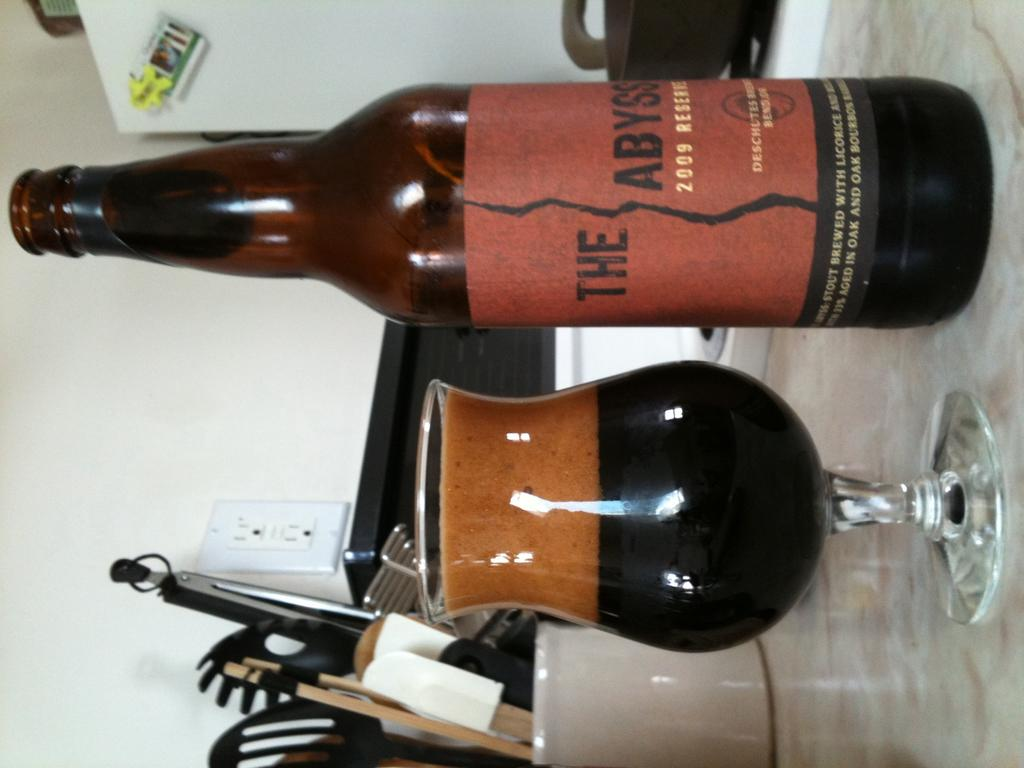What type of container is visible in the image? There is a glass in the image. What other container can be seen in the image? There is a bottle in the image. Can you identify any text or writing in the image? Yes, there is writing on an object in the image. What can be seen in the background of the image? There are background elements visible in the image. What color is the power socket in the image? The power socket in the image is white-colored. How many deer are resting in the image? There are no deer present in the image. What level of difficulty is the image set at? The image does not have a level of difficulty, as it is a still image and not a game or challenge. 